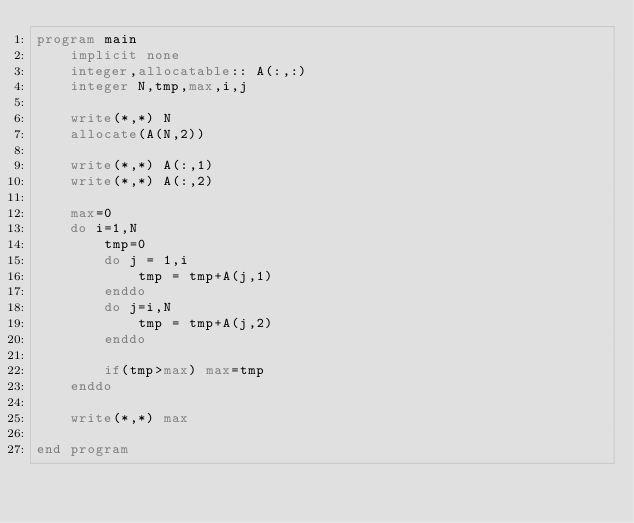<code> <loc_0><loc_0><loc_500><loc_500><_FORTRAN_>program main
    implicit none
    integer,allocatable:: A(:,:)
    integer N,tmp,max,i,j

    write(*,*) N
    allocate(A(N,2))
    
    write(*,*) A(:,1)
    write(*,*) A(:,2)

    max=0
    do i=1,N
        tmp=0
        do j = 1,i
            tmp = tmp+A(j,1)
        enddo
        do j=i,N
            tmp = tmp+A(j,2)
        enddo

        if(tmp>max) max=tmp
    enddo

    write(*,*) max

end program</code> 